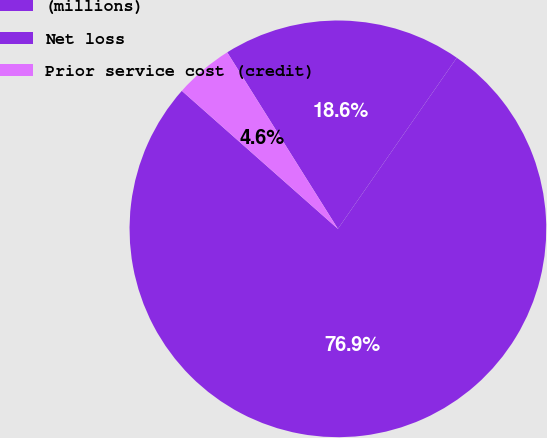<chart> <loc_0><loc_0><loc_500><loc_500><pie_chart><fcel>(millions)<fcel>Net loss<fcel>Prior service cost (credit)<nl><fcel>76.86%<fcel>18.58%<fcel>4.56%<nl></chart> 